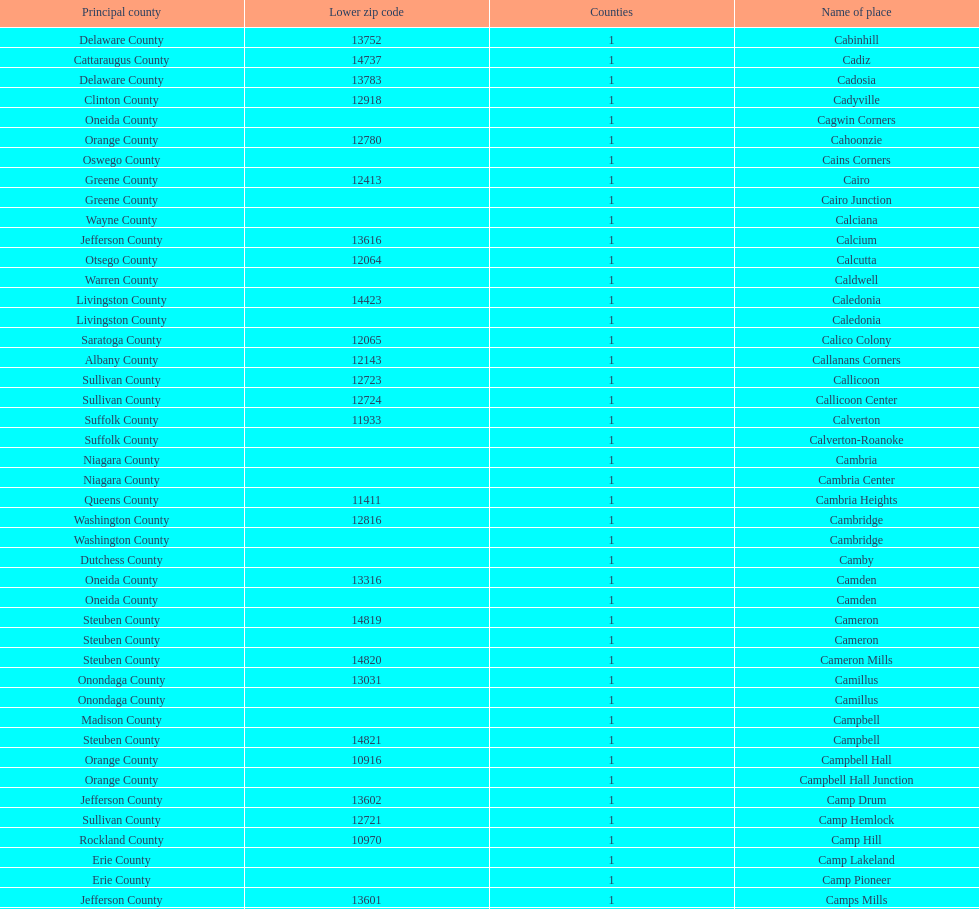How many places are in greene county? 10. 